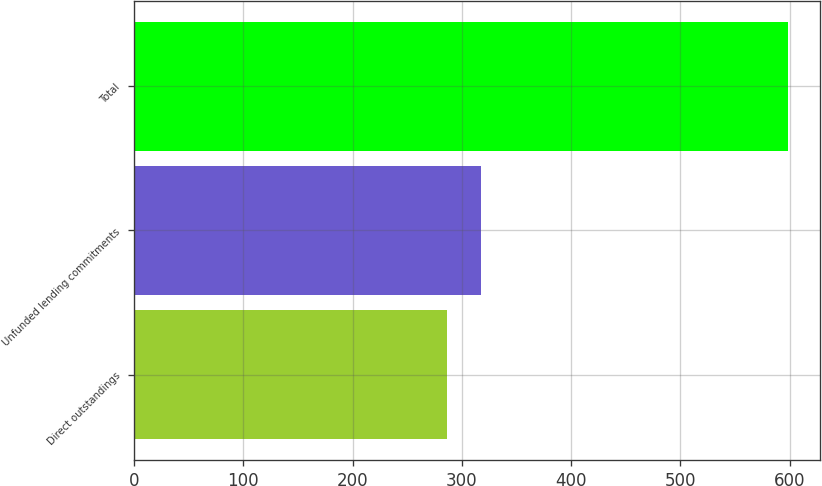<chart> <loc_0><loc_0><loc_500><loc_500><bar_chart><fcel>Direct outstandings<fcel>Unfunded lending commitments<fcel>Total<nl><fcel>286<fcel>317.2<fcel>598<nl></chart> 